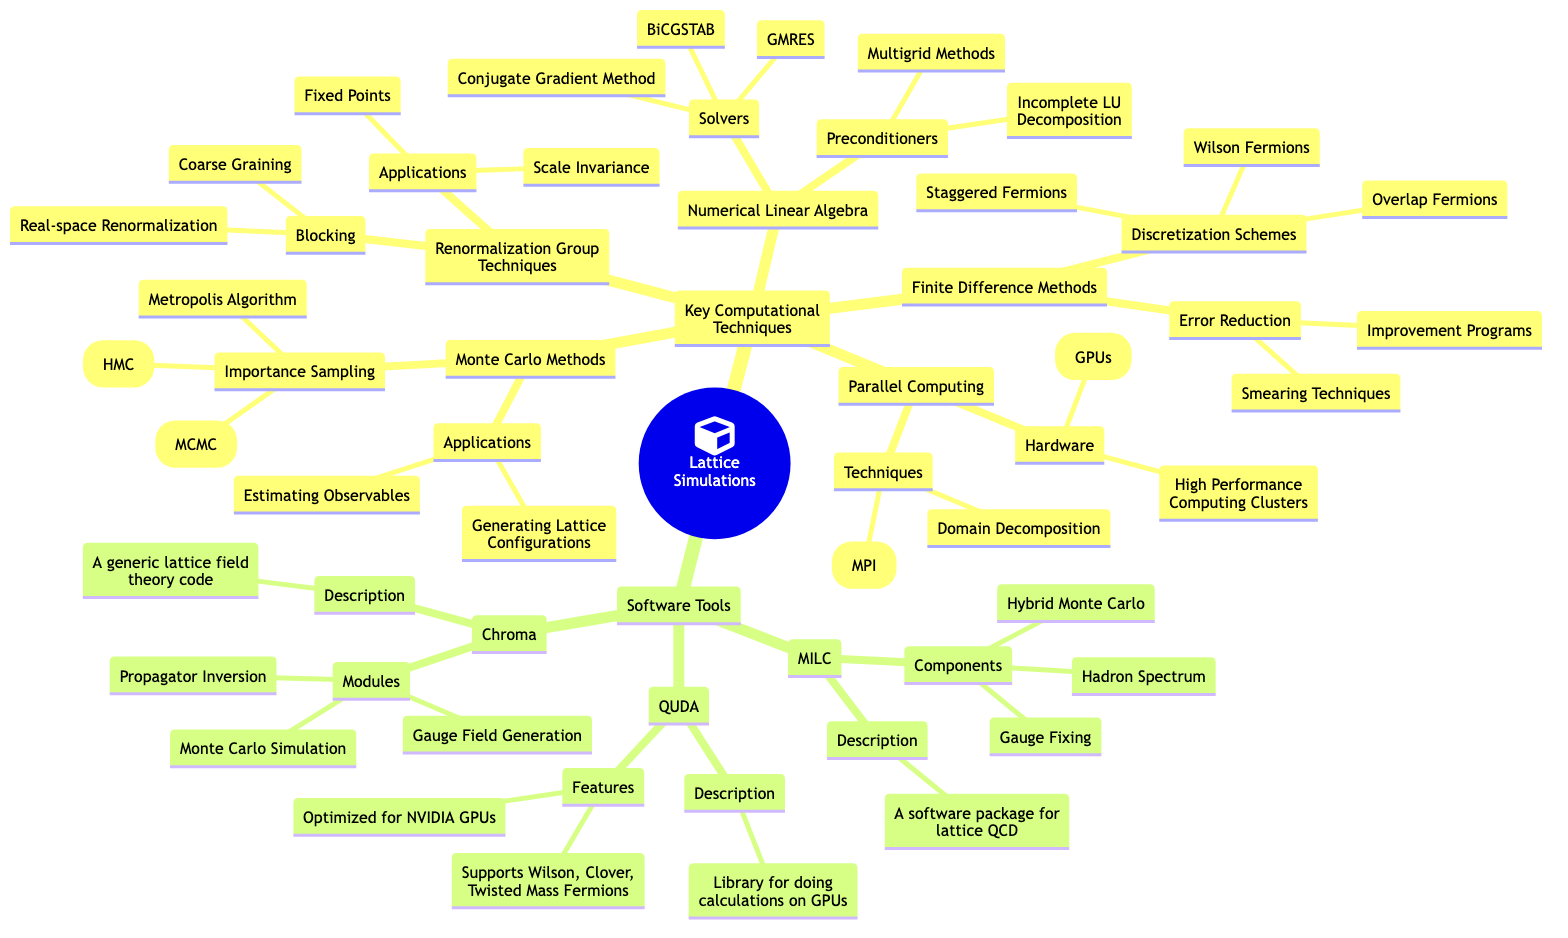What is a key technique used in Monte Carlo Methods? The diagram lists "Importance Sampling" as a key technique under "Monte Carlo Methods." It is a specific approach used to carry out simulations more efficiently by focusing on more probable outcomes.
Answer: Importance Sampling How many solvers are listed under Numerical Linear Algebra? The diagram presents three solvers under the "Solvers" node in "Numerical Linear Algebra": Conjugate Gradient Method, BiCGSTAB, and GMRES, which amounts to a total of three.
Answer: 3 What are the two hardware options mentioned in Parallel Computing? Under the "Hardware" node, the diagram identifies "High Performance Computing Clusters" and "Graphics Processing Units (GPUs)" as the two hardware options available.
Answer: High Performance Computing Clusters and Graphics Processing Units Which technique under Renormalization Group Techniques involves coarse graining? "Coarse Graining" is explicitly listed as a type of blocking technique under the "Blocking" node within "Renormalization Group Techniques."
Answer: Coarse Graining How many software tools are mentioned in the diagram? The diagram outlines three software tools: MILC, QUDA, and Chroma, thus we can conclude there are three software tools listed.
Answer: 3 What types of discretization schemes are identified in Finite Difference Methods? The section on "Discretization Schemes" within "Finite Difference Methods" mentions three types: Staggered Fermions, Wilson Fermions, and Overlap Fermions, making it clear there are three listed schemes.
Answer: Staggered Fermions, Wilson Fermions, Overlap Fermions What is the main application of Monte Carlo Methods? The diagram indicates that "Estimating Observables" and "Generating Lattice Configurations" are applications of Monte Carlo Methods. Since the question asks for a main application, both could be seen as equally relevant, but "Estimating Observables" is presented first.
Answer: Estimating Observables What features does QUDA support? The diagram states that QUDA supports "Wilson, Clover, Twisted Mass Fermions" as its features. This highlights the versatility of the library in handling different types of fermion formulations used in lattice simulations.
Answer: Wilson, Clover, Twisted Mass Fermions What preconditioners are mentioned under Numerical Linear Algebra? Under the section titled "Preconditioners" in "Numerical Linear Algebra," the diagram lists "Incomplete LU Decomposition" and "Multigrid Methods," which are both techniques used to improve the efficiency of solvers.
Answer: Incomplete LU Decomposition, Multigrid Methods 